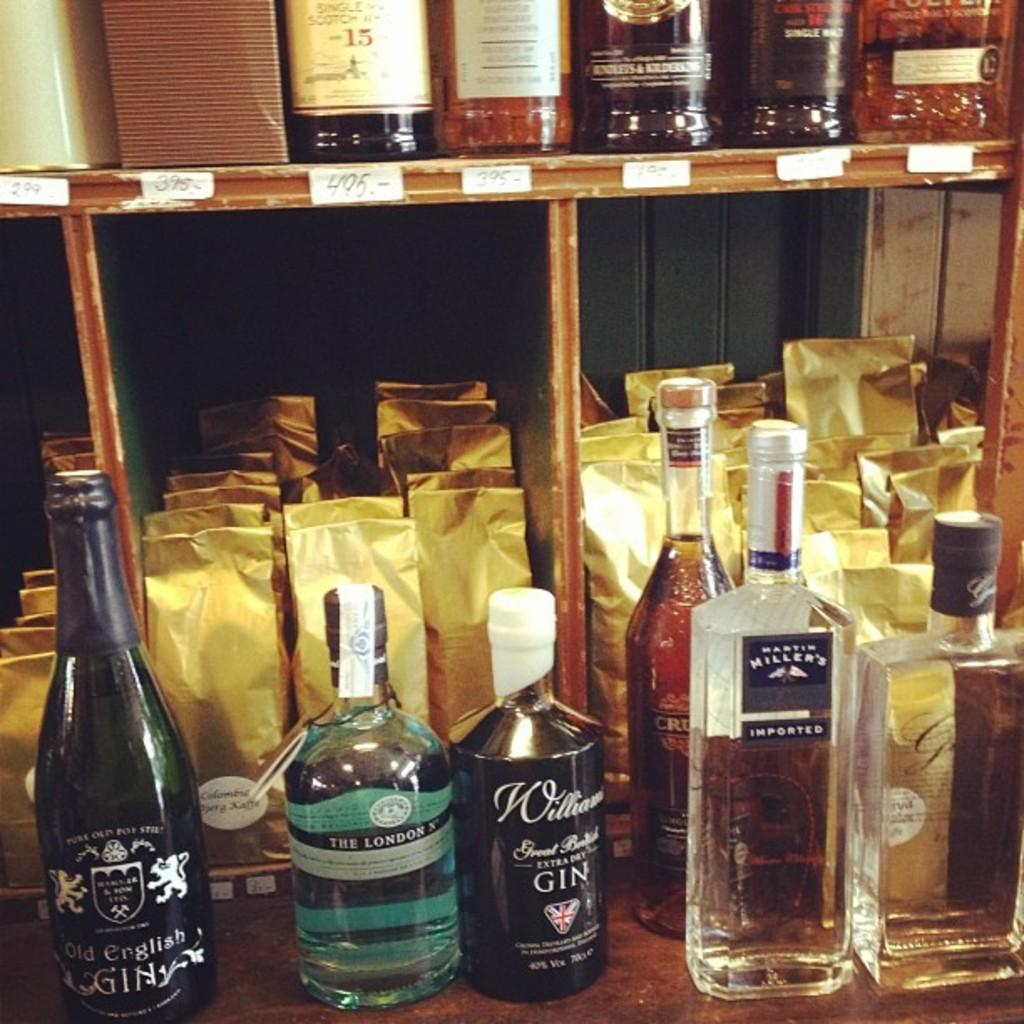<image>
Write a terse but informative summary of the picture. Bottles of liquid with one that says Imported on it. 